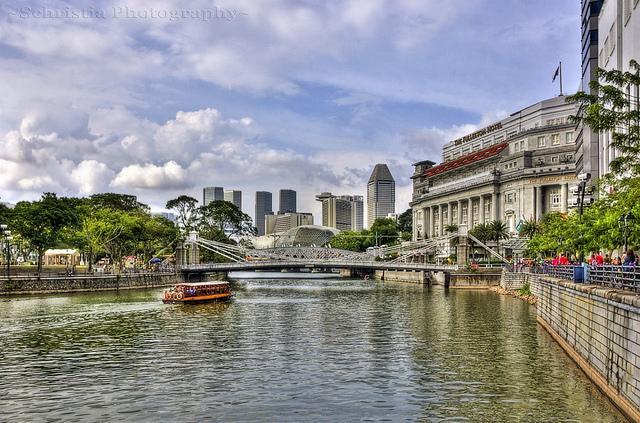Is there an animal on the water?
Answer briefly. No. Where is the bridge?
Short answer required. Over river. What are the people holding above their heads?
Write a very short answer. Nothing. Is there a walkway where people can stand?
Be succinct. Yes. What is floating in the water?
Short answer required. Boat. 